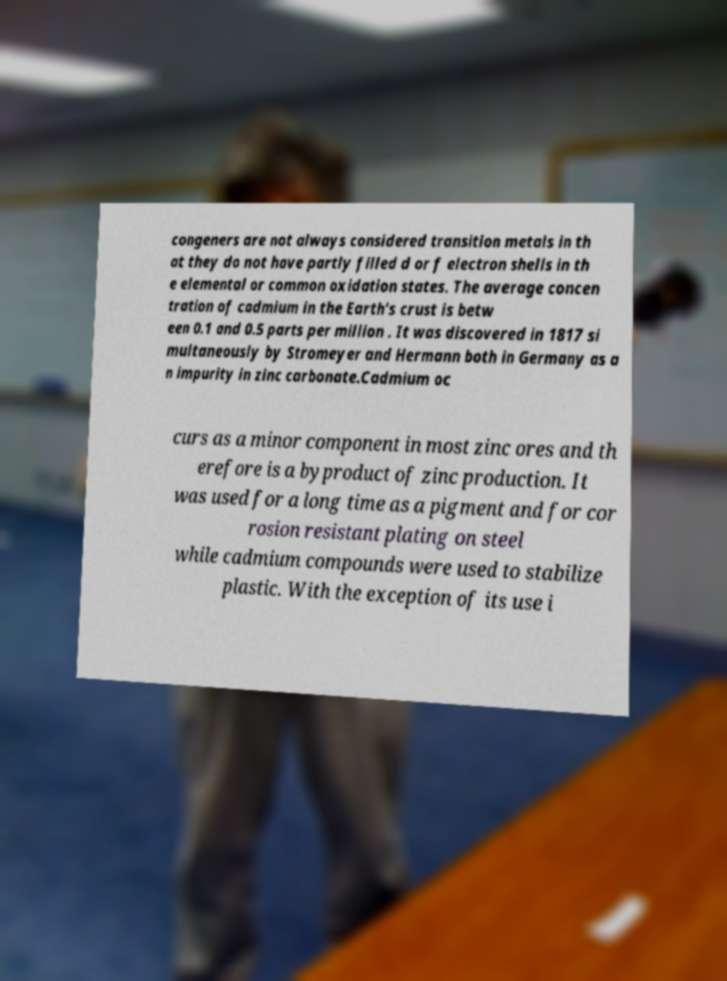Please read and relay the text visible in this image. What does it say? congeners are not always considered transition metals in th at they do not have partly filled d or f electron shells in th e elemental or common oxidation states. The average concen tration of cadmium in the Earth's crust is betw een 0.1 and 0.5 parts per million . It was discovered in 1817 si multaneously by Stromeyer and Hermann both in Germany as a n impurity in zinc carbonate.Cadmium oc curs as a minor component in most zinc ores and th erefore is a byproduct of zinc production. It was used for a long time as a pigment and for cor rosion resistant plating on steel while cadmium compounds were used to stabilize plastic. With the exception of its use i 